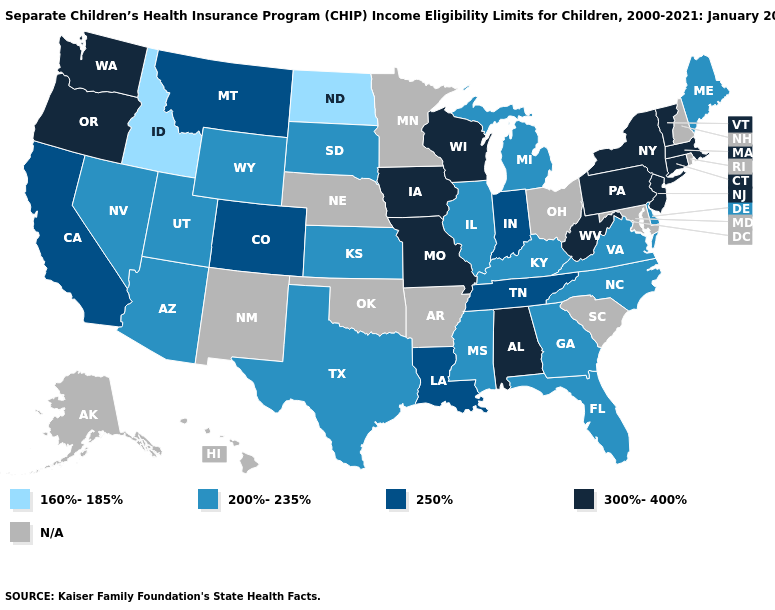What is the value of New York?
Be succinct. 300%-400%. What is the value of Utah?
Give a very brief answer. 200%-235%. Which states have the lowest value in the USA?
Be succinct. Idaho, North Dakota. Name the states that have a value in the range 300%-400%?
Answer briefly. Alabama, Connecticut, Iowa, Massachusetts, Missouri, New Jersey, New York, Oregon, Pennsylvania, Vermont, Washington, West Virginia, Wisconsin. Which states hav the highest value in the West?
Short answer required. Oregon, Washington. Does Idaho have the lowest value in the West?
Give a very brief answer. Yes. What is the value of Washington?
Short answer required. 300%-400%. What is the value of North Carolina?
Answer briefly. 200%-235%. Among the states that border Pennsylvania , which have the lowest value?
Keep it brief. Delaware. Does the map have missing data?
Quick response, please. Yes. What is the lowest value in states that border Iowa?
Keep it brief. 200%-235%. Which states have the highest value in the USA?
Keep it brief. Alabama, Connecticut, Iowa, Massachusetts, Missouri, New Jersey, New York, Oregon, Pennsylvania, Vermont, Washington, West Virginia, Wisconsin. 